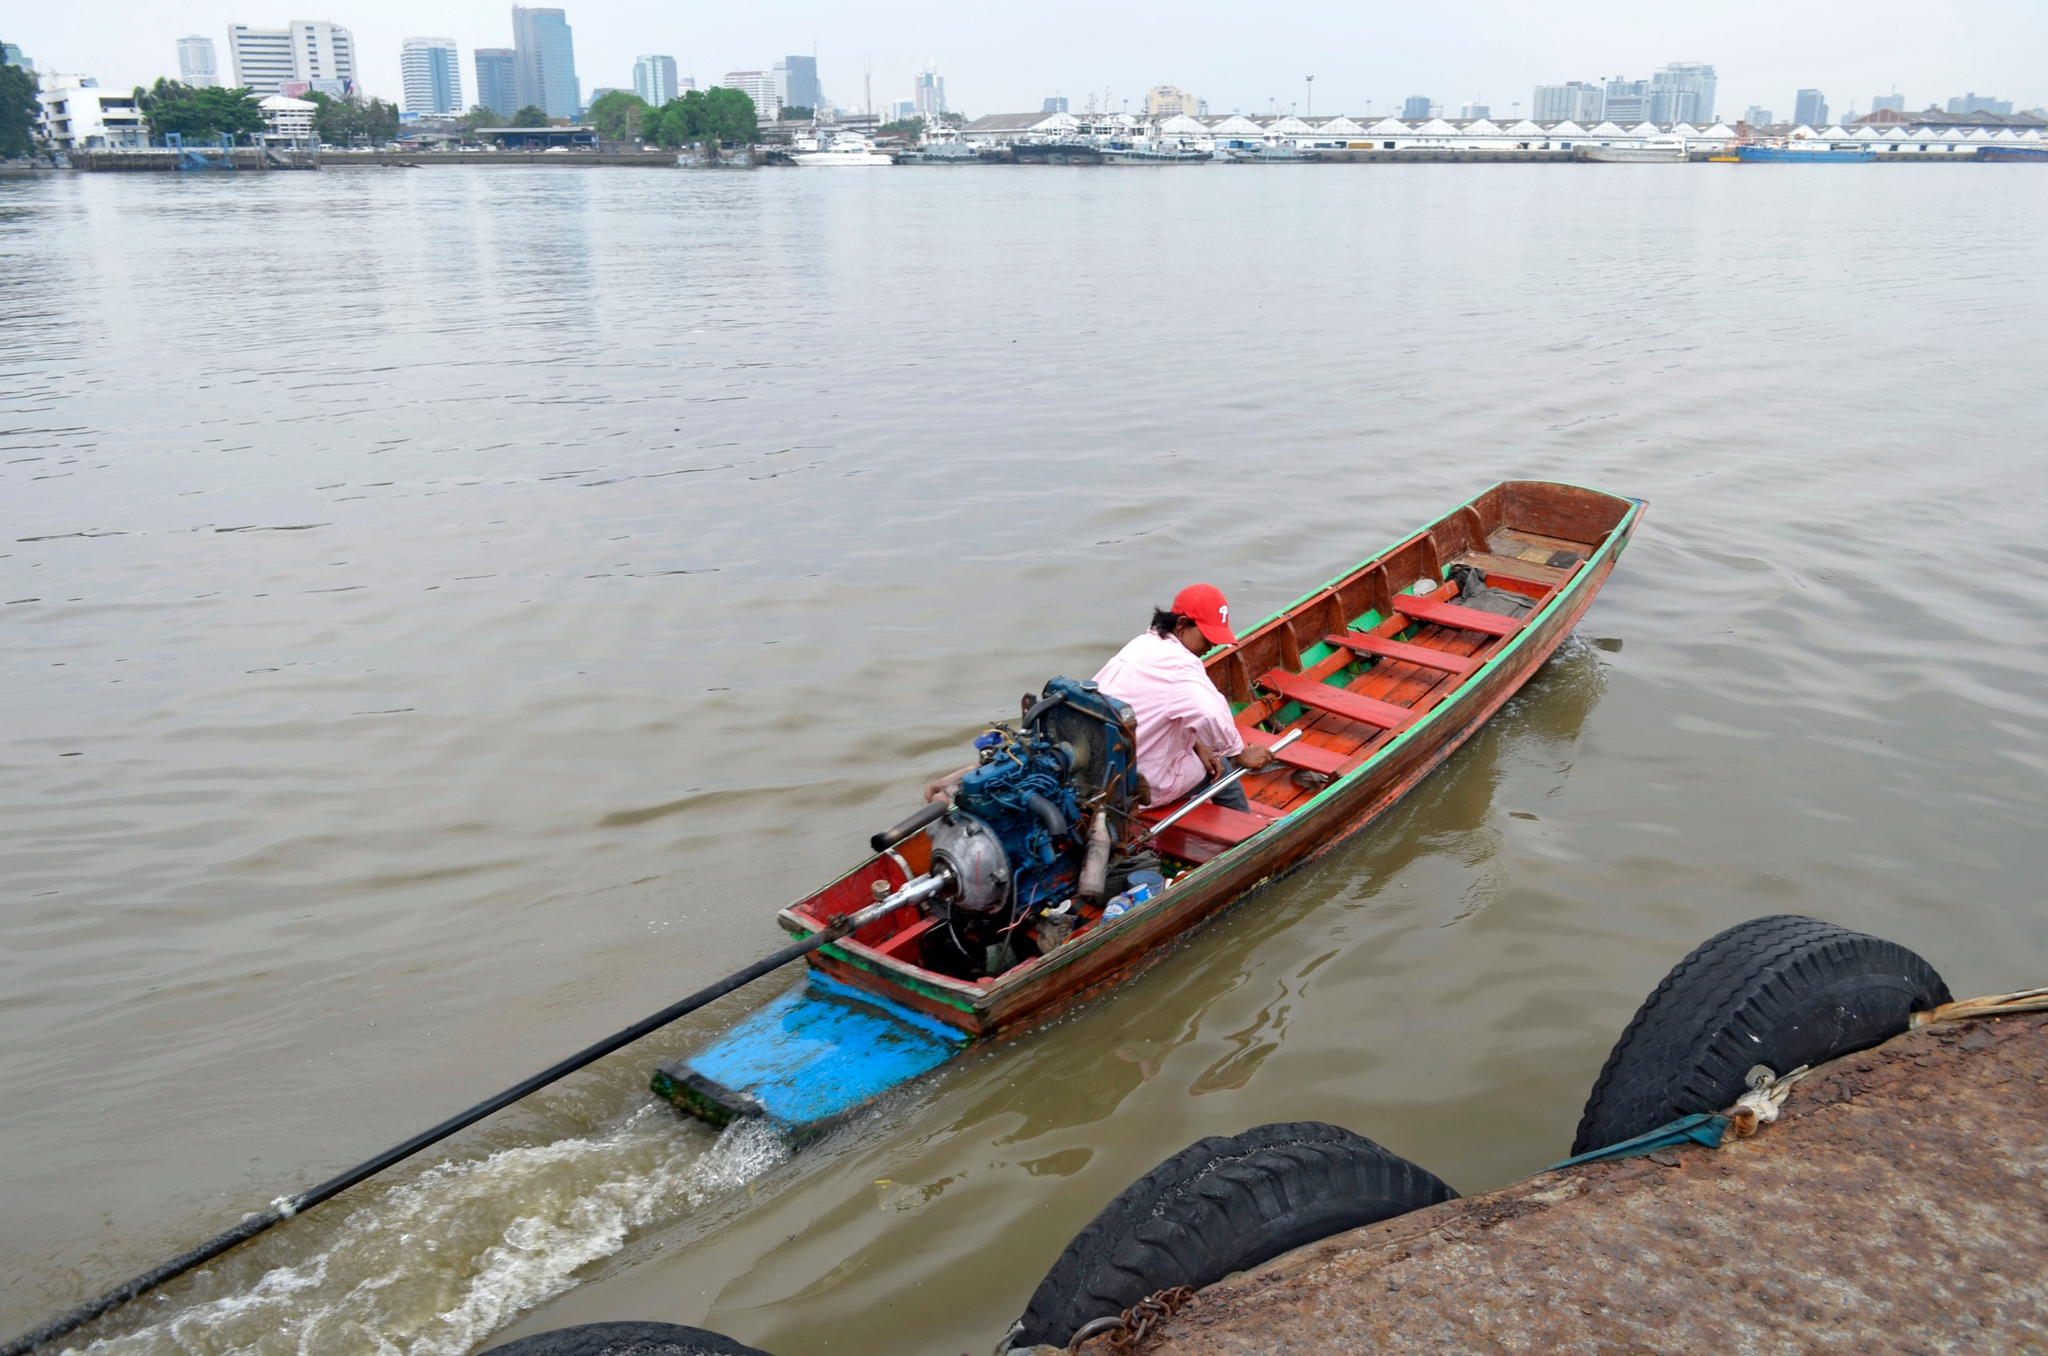Write a detailed description of the given image. The image captures a serene moment of a person navigating a calm river in a traditional wooden boat painted in vibrant red and blue. The boat is equipped with a motor at the rear, causing gentle ripples to form in the otherwise still, grayish-blue water. Black tires are neatly placed along the side of the boat to potentially cushion against impact. The person steering the boat is wearing a pink shirt paired with a white hat, and a red baseball cap, appearing to enjoy a leisurely ride on the water.

In the background, the city skyline with various buildings of different heights contrasts with the tranquil waters, suggesting a blend of urban life and nature. An overcast sky adds a touch of calmness to the scene, emphasizing the peaceful ambiance. The photo’s perspective, seemingly taken from a low vantage point perhaps from another boat or the riverbank, further enhances the sense of proximity to the water.

Regarding the specific landmark identification (sa_12200), there is no direct recognition of this reference in available resources. Therefore, pinpointing the exact location remains inconclusive. However, the cityscape in the background could serve as a potential clue if additional context were provided. 